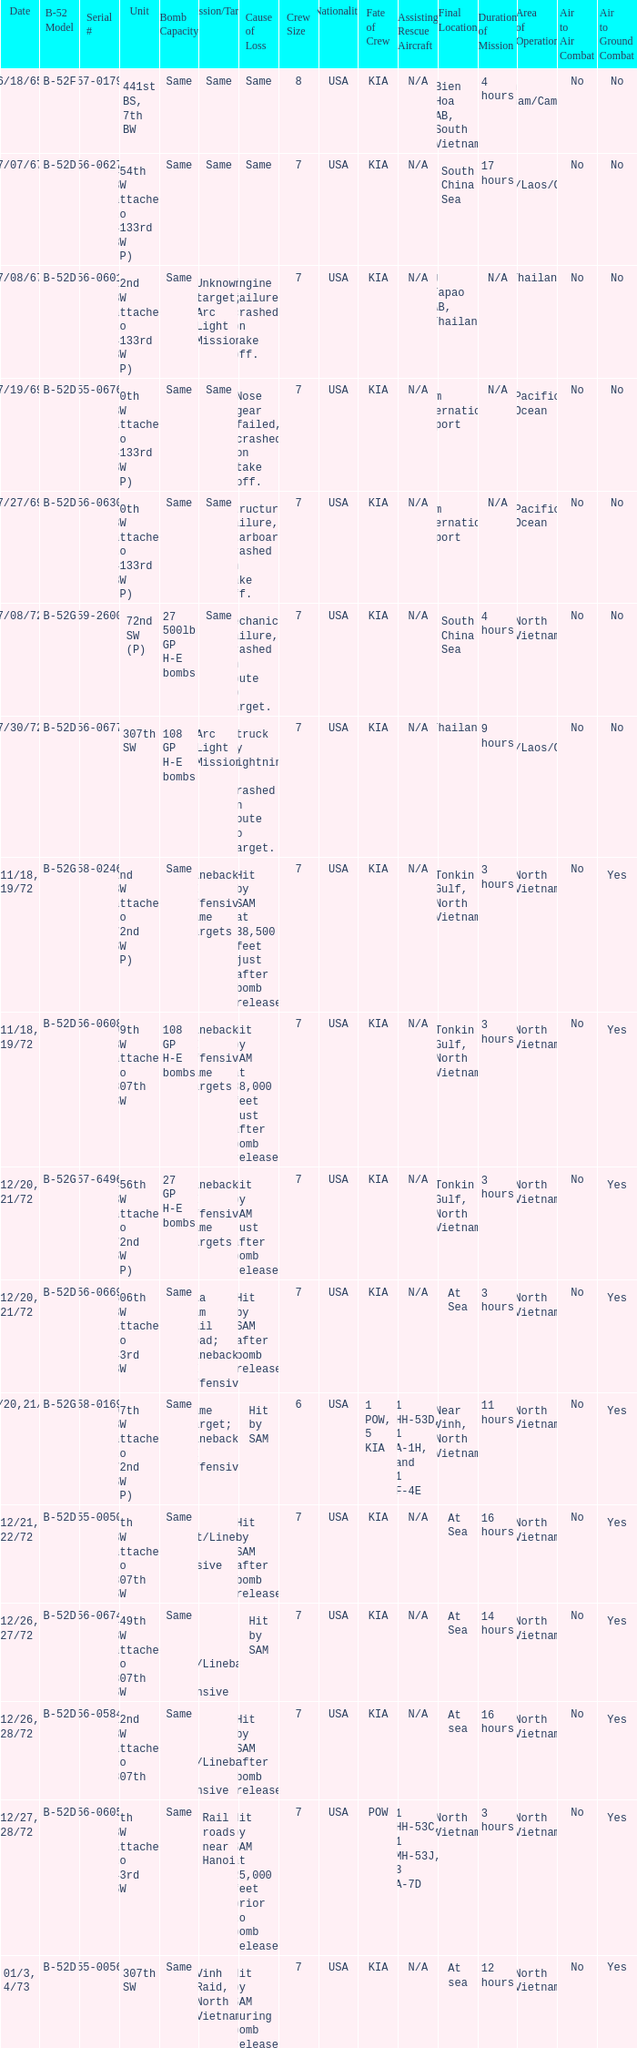When 7th bw attached to 43rd sw is the unit what is the b-52 model? B-52D. 